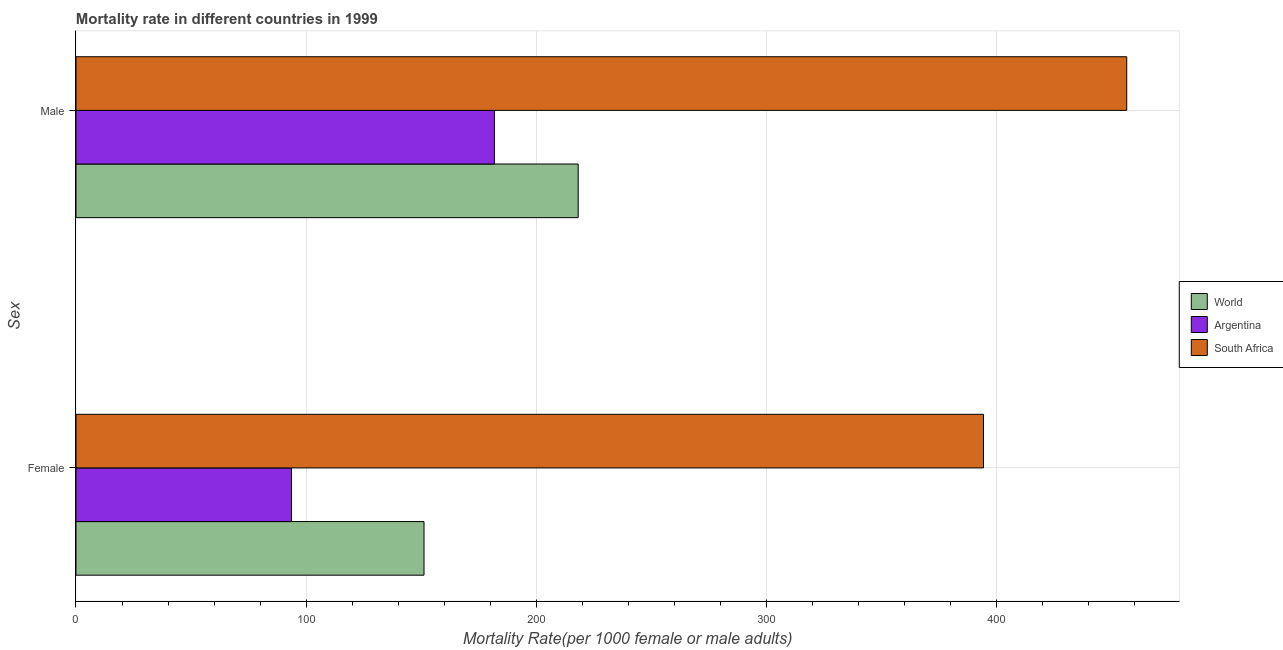How many bars are there on the 1st tick from the bottom?
Offer a terse response. 3. What is the male mortality rate in World?
Your answer should be compact. 218.16. Across all countries, what is the maximum female mortality rate?
Make the answer very short. 394.24. Across all countries, what is the minimum male mortality rate?
Your answer should be compact. 181.76. In which country was the female mortality rate maximum?
Your answer should be very brief. South Africa. What is the total male mortality rate in the graph?
Your answer should be compact. 856.4. What is the difference between the female mortality rate in Argentina and that in South Africa?
Your response must be concise. -300.63. What is the difference between the male mortality rate in Argentina and the female mortality rate in South Africa?
Your answer should be compact. -212.48. What is the average female mortality rate per country?
Provide a short and direct response. 213.01. What is the difference between the male mortality rate and female mortality rate in South Africa?
Offer a terse response. 62.23. What is the ratio of the female mortality rate in South Africa to that in World?
Your answer should be very brief. 2.61. Is the female mortality rate in World less than that in South Africa?
Provide a short and direct response. Yes. In how many countries, is the female mortality rate greater than the average female mortality rate taken over all countries?
Offer a terse response. 1. What does the 2nd bar from the bottom in Male represents?
Keep it short and to the point. Argentina. How many bars are there?
Your response must be concise. 6. Are all the bars in the graph horizontal?
Your answer should be very brief. Yes. What is the difference between two consecutive major ticks on the X-axis?
Ensure brevity in your answer.  100. Are the values on the major ticks of X-axis written in scientific E-notation?
Keep it short and to the point. No. Does the graph contain any zero values?
Your response must be concise. No. How are the legend labels stacked?
Offer a terse response. Vertical. What is the title of the graph?
Provide a short and direct response. Mortality rate in different countries in 1999. Does "Armenia" appear as one of the legend labels in the graph?
Make the answer very short. No. What is the label or title of the X-axis?
Offer a very short reply. Mortality Rate(per 1000 female or male adults). What is the label or title of the Y-axis?
Ensure brevity in your answer.  Sex. What is the Mortality Rate(per 1000 female or male adults) in World in Female?
Ensure brevity in your answer.  151.19. What is the Mortality Rate(per 1000 female or male adults) in Argentina in Female?
Your answer should be very brief. 93.61. What is the Mortality Rate(per 1000 female or male adults) of South Africa in Female?
Keep it short and to the point. 394.24. What is the Mortality Rate(per 1000 female or male adults) of World in Male?
Provide a succinct answer. 218.16. What is the Mortality Rate(per 1000 female or male adults) in Argentina in Male?
Offer a very short reply. 181.76. What is the Mortality Rate(per 1000 female or male adults) of South Africa in Male?
Provide a succinct answer. 456.47. Across all Sex, what is the maximum Mortality Rate(per 1000 female or male adults) of World?
Ensure brevity in your answer.  218.16. Across all Sex, what is the maximum Mortality Rate(per 1000 female or male adults) of Argentina?
Make the answer very short. 181.76. Across all Sex, what is the maximum Mortality Rate(per 1000 female or male adults) in South Africa?
Provide a short and direct response. 456.47. Across all Sex, what is the minimum Mortality Rate(per 1000 female or male adults) of World?
Make the answer very short. 151.19. Across all Sex, what is the minimum Mortality Rate(per 1000 female or male adults) of Argentina?
Provide a succinct answer. 93.61. Across all Sex, what is the minimum Mortality Rate(per 1000 female or male adults) of South Africa?
Ensure brevity in your answer.  394.24. What is the total Mortality Rate(per 1000 female or male adults) in World in the graph?
Make the answer very short. 369.35. What is the total Mortality Rate(per 1000 female or male adults) of Argentina in the graph?
Your answer should be compact. 275.37. What is the total Mortality Rate(per 1000 female or male adults) of South Africa in the graph?
Ensure brevity in your answer.  850.71. What is the difference between the Mortality Rate(per 1000 female or male adults) in World in Female and that in Male?
Keep it short and to the point. -66.98. What is the difference between the Mortality Rate(per 1000 female or male adults) of Argentina in Female and that in Male?
Keep it short and to the point. -88.15. What is the difference between the Mortality Rate(per 1000 female or male adults) in South Africa in Female and that in Male?
Your answer should be compact. -62.23. What is the difference between the Mortality Rate(per 1000 female or male adults) in World in Female and the Mortality Rate(per 1000 female or male adults) in Argentina in Male?
Provide a succinct answer. -30.57. What is the difference between the Mortality Rate(per 1000 female or male adults) in World in Female and the Mortality Rate(per 1000 female or male adults) in South Africa in Male?
Provide a succinct answer. -305.28. What is the difference between the Mortality Rate(per 1000 female or male adults) in Argentina in Female and the Mortality Rate(per 1000 female or male adults) in South Africa in Male?
Ensure brevity in your answer.  -362.87. What is the average Mortality Rate(per 1000 female or male adults) in World per Sex?
Ensure brevity in your answer.  184.68. What is the average Mortality Rate(per 1000 female or male adults) of Argentina per Sex?
Keep it short and to the point. 137.68. What is the average Mortality Rate(per 1000 female or male adults) of South Africa per Sex?
Your answer should be very brief. 425.35. What is the difference between the Mortality Rate(per 1000 female or male adults) in World and Mortality Rate(per 1000 female or male adults) in Argentina in Female?
Provide a short and direct response. 57.58. What is the difference between the Mortality Rate(per 1000 female or male adults) of World and Mortality Rate(per 1000 female or male adults) of South Africa in Female?
Offer a terse response. -243.05. What is the difference between the Mortality Rate(per 1000 female or male adults) of Argentina and Mortality Rate(per 1000 female or male adults) of South Africa in Female?
Your answer should be compact. -300.63. What is the difference between the Mortality Rate(per 1000 female or male adults) of World and Mortality Rate(per 1000 female or male adults) of Argentina in Male?
Keep it short and to the point. 36.4. What is the difference between the Mortality Rate(per 1000 female or male adults) of World and Mortality Rate(per 1000 female or male adults) of South Africa in Male?
Give a very brief answer. -238.31. What is the difference between the Mortality Rate(per 1000 female or male adults) in Argentina and Mortality Rate(per 1000 female or male adults) in South Africa in Male?
Provide a succinct answer. -274.71. What is the ratio of the Mortality Rate(per 1000 female or male adults) in World in Female to that in Male?
Offer a very short reply. 0.69. What is the ratio of the Mortality Rate(per 1000 female or male adults) in Argentina in Female to that in Male?
Make the answer very short. 0.52. What is the ratio of the Mortality Rate(per 1000 female or male adults) of South Africa in Female to that in Male?
Offer a terse response. 0.86. What is the difference between the highest and the second highest Mortality Rate(per 1000 female or male adults) of World?
Give a very brief answer. 66.98. What is the difference between the highest and the second highest Mortality Rate(per 1000 female or male adults) in Argentina?
Provide a short and direct response. 88.15. What is the difference between the highest and the second highest Mortality Rate(per 1000 female or male adults) in South Africa?
Provide a short and direct response. 62.23. What is the difference between the highest and the lowest Mortality Rate(per 1000 female or male adults) in World?
Offer a terse response. 66.98. What is the difference between the highest and the lowest Mortality Rate(per 1000 female or male adults) in Argentina?
Provide a short and direct response. 88.15. What is the difference between the highest and the lowest Mortality Rate(per 1000 female or male adults) of South Africa?
Provide a succinct answer. 62.23. 